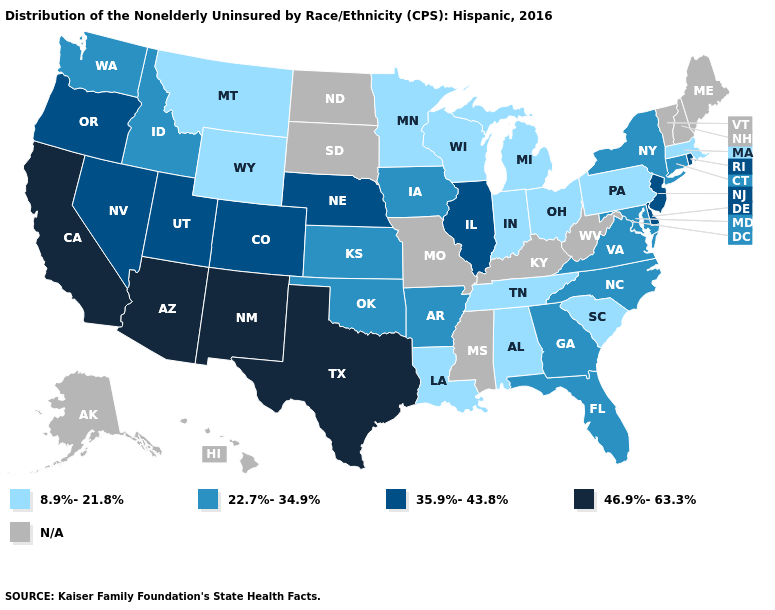What is the highest value in the USA?
Be succinct. 46.9%-63.3%. Does Colorado have the lowest value in the USA?
Give a very brief answer. No. Which states have the lowest value in the USA?
Short answer required. Alabama, Indiana, Louisiana, Massachusetts, Michigan, Minnesota, Montana, Ohio, Pennsylvania, South Carolina, Tennessee, Wisconsin, Wyoming. What is the value of Nevada?
Keep it brief. 35.9%-43.8%. What is the lowest value in the USA?
Give a very brief answer. 8.9%-21.8%. Name the states that have a value in the range 46.9%-63.3%?
Answer briefly. Arizona, California, New Mexico, Texas. What is the highest value in the USA?
Write a very short answer. 46.9%-63.3%. Is the legend a continuous bar?
Concise answer only. No. Which states hav the highest value in the Northeast?
Write a very short answer. New Jersey, Rhode Island. Among the states that border Minnesota , does Iowa have the lowest value?
Answer briefly. No. What is the lowest value in the USA?
Short answer required. 8.9%-21.8%. Does the first symbol in the legend represent the smallest category?
Answer briefly. Yes. What is the lowest value in the South?
Give a very brief answer. 8.9%-21.8%. What is the value of Nevada?
Concise answer only. 35.9%-43.8%. What is the value of New York?
Be succinct. 22.7%-34.9%. 